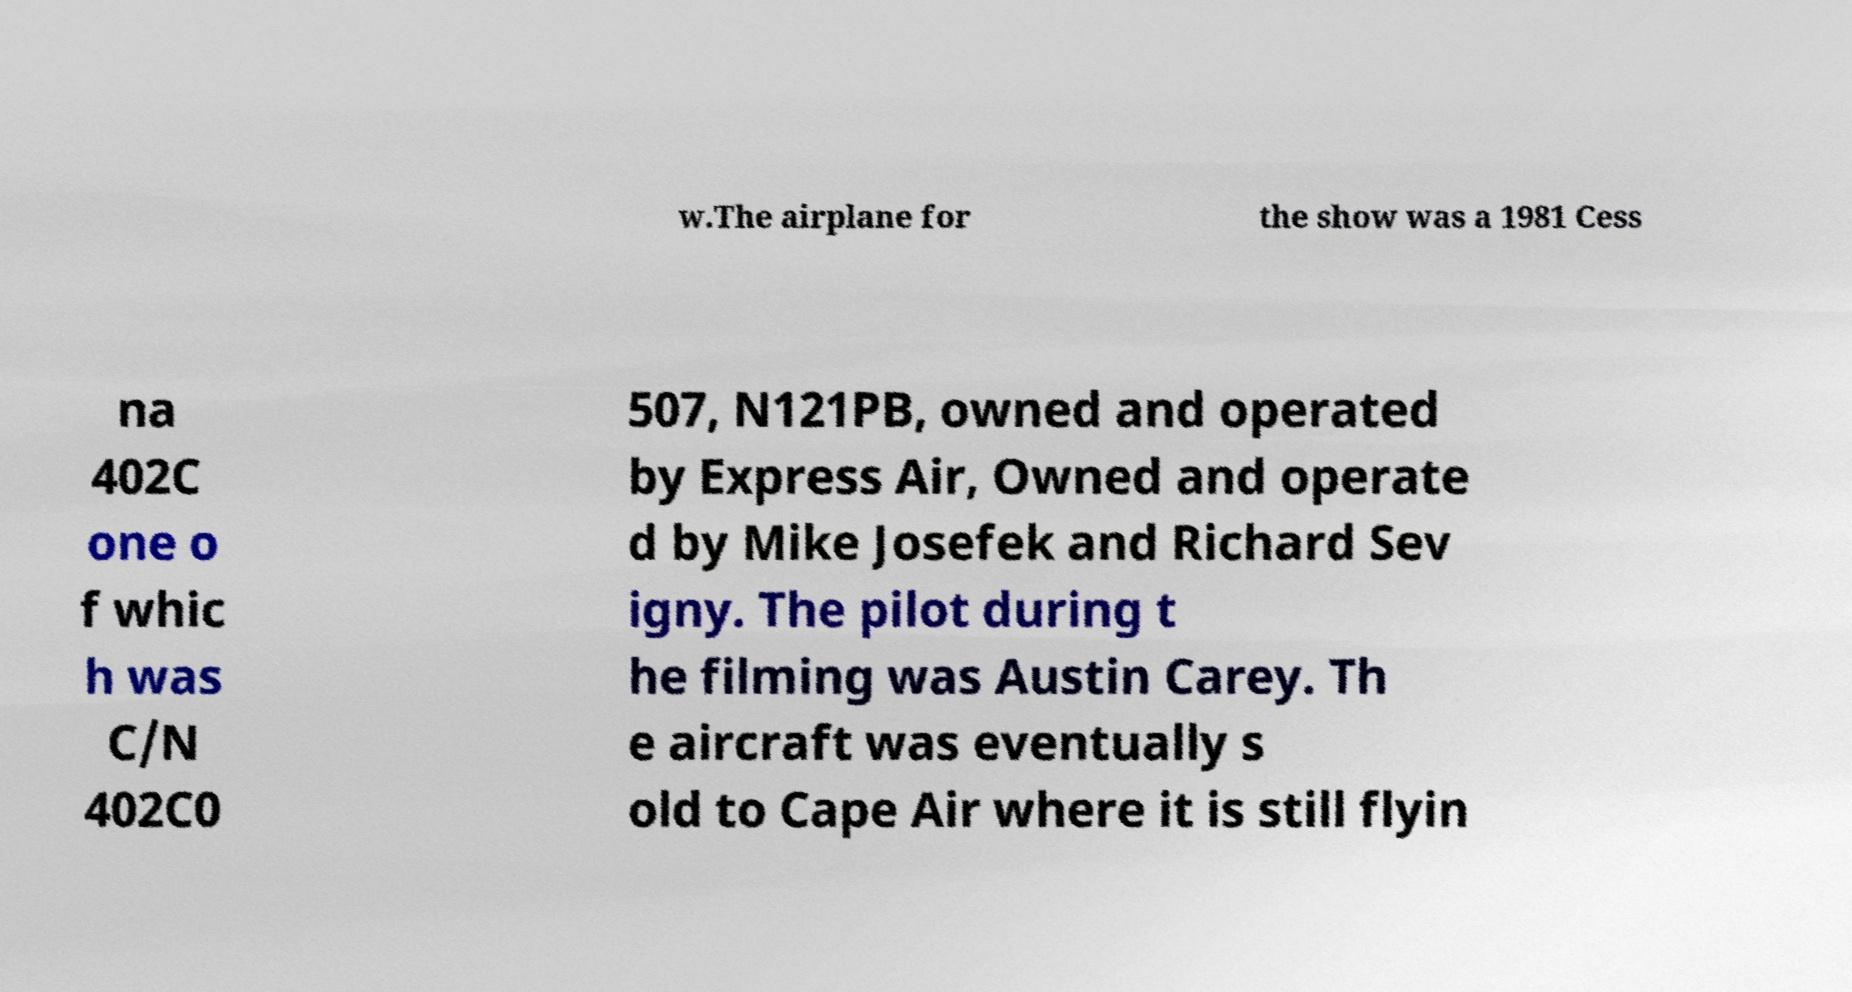What messages or text are displayed in this image? I need them in a readable, typed format. w.The airplane for the show was a 1981 Cess na 402C one o f whic h was C/N 402C0 507, N121PB, owned and operated by Express Air, Owned and operate d by Mike Josefek and Richard Sev igny. The pilot during t he filming was Austin Carey. Th e aircraft was eventually s old to Cape Air where it is still flyin 